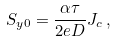Convert formula to latex. <formula><loc_0><loc_0><loc_500><loc_500>S _ { y 0 } = \frac { \alpha \tau } { 2 e D } J _ { c } \, ,</formula> 